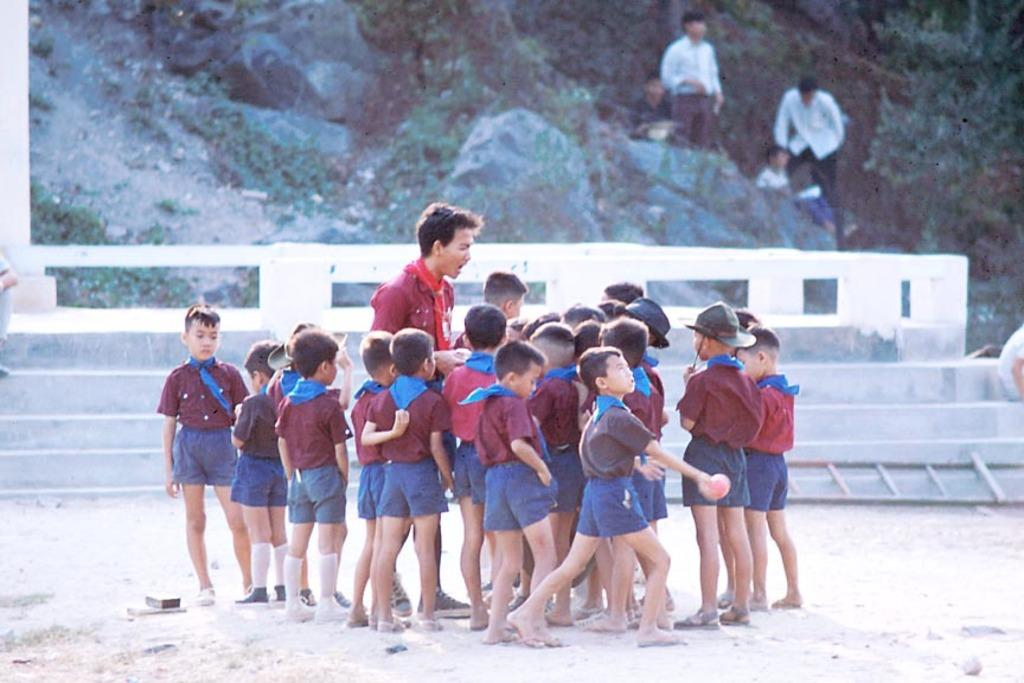How many people are in the image? There are people in the image, but the exact number is not specified. Where are some of the people located in the image? Some people are standing on the ground, while others are on the mountains. What is a feature in the image that allows people to move between different levels? There is a staircase in the image that people can use to move between different levels. What type of natural vegetation is present in the image? There are trees in the image. What type of yam is being used as a prop in the image? There is no yam present in the image; it features people, mountains, a staircase, and trees. 